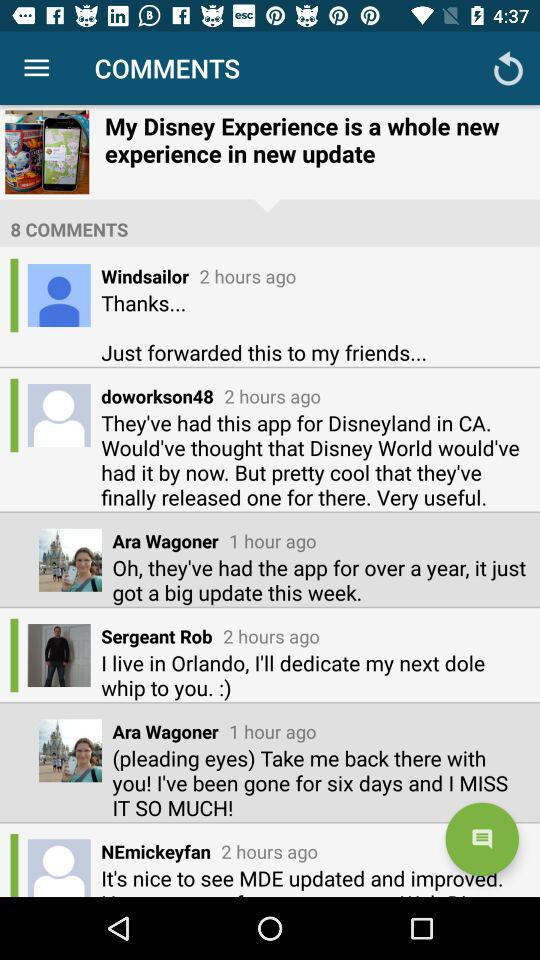How many comments are there on this post?
Answer the question using a single word or phrase. 8 